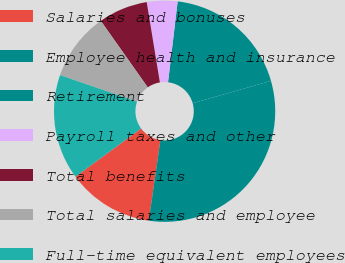Convert chart. <chart><loc_0><loc_0><loc_500><loc_500><pie_chart><fcel>Salaries and bonuses<fcel>Employee health and insurance<fcel>Retirement<fcel>Payroll taxes and other<fcel>Total benefits<fcel>Total salaries and employee<fcel>Full-time equivalent employees<nl><fcel>12.64%<fcel>31.71%<fcel>18.7%<fcel>4.47%<fcel>7.2%<fcel>9.92%<fcel>15.37%<nl></chart> 